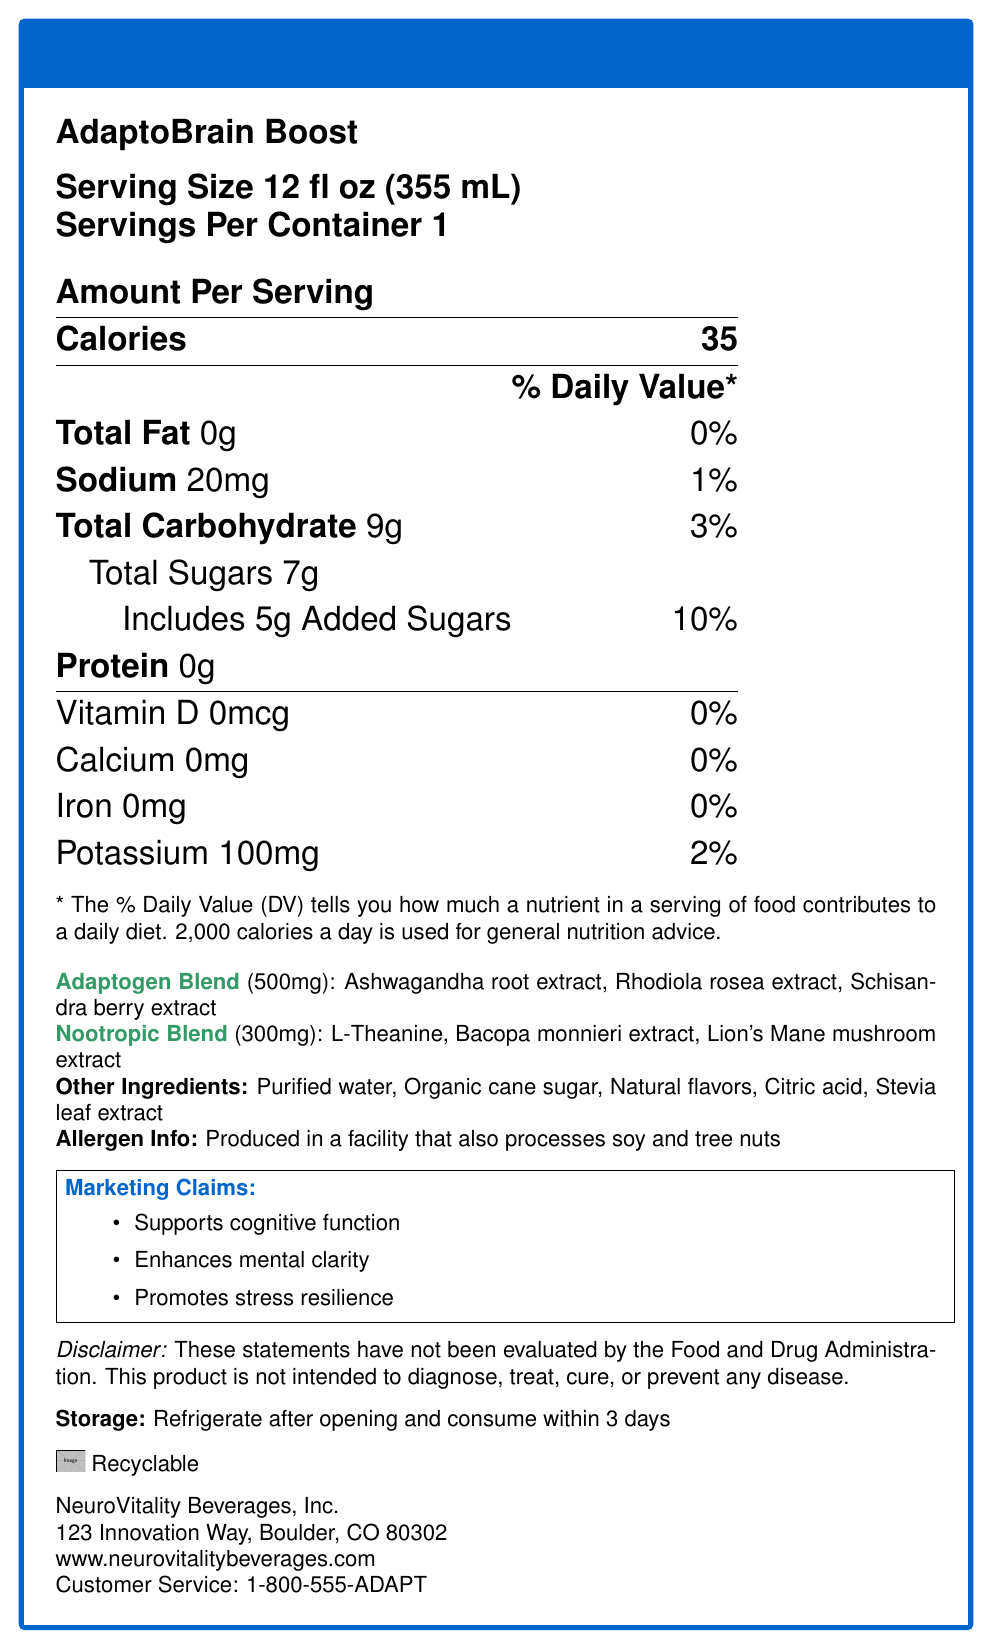what is the serving size of the AdaptoBrain Boost beverage? The serving size is clearly mentioned as "12 fl oz (355 mL)" on the document.
Answer: 12 fl oz (355 mL) how many grams of sugar are in one serving of AdaptoBrain Boost? The document lists the total sugars amount as 7g per serving.
Answer: 7g what percentage of the daily value is the sodium content in one serving? The sodium content is listed as 20mg, which is 1% of the daily value.
Answer: 1% what unique ingredients are found in the adaptogen blend? The adaptogen blend includes Ashwagandha root extract, Rhodiola rosea extract, and Schisandra berry extract.
Answer: Ashwagandha root extract, Rhodiola rosea extract, Schisandra berry extract which types of nootropics are included in the AdaptoBrain Boost beverage? The nootropic blend contains L-Theanine, Bacopa monnieri extract, and Lion's Mane mushroom extract.
Answer: L-Theanine, Bacopa monnieri extract, Lion's Mane mushroom extract what is the calorie count per serving of AdaptoBrain Boost? The document states that there are 35 calories per serving.
Answer: 35 how should this product be stored after opening? The storage instructions state to refrigerate after opening and consume within 3 days.
Answer: Refrigerate after opening and consume within 3 days which company produces AdaptoBrain Boost? The company listed is NeuroVitality Beverages, Inc.
Answer: NeuroVitality Beverages, Inc. what are the daily value percentages of vitamin D and calcium in one serving? Both vitamin D and calcium are listed as 0% of the daily value.
Answer: 0% for both is the product recyclable? The document indicates that the product is recyclable.
Answer: Yes which of the following ingredients is not in AdaptoBrain Boost? A. Organic cane sugar B. Natural flavors C. Artificial sweeteners The document lists organic cane sugar and natural flavors but does not mention artificial sweeteners.
Answer: C. Artificial sweeteners how many servings are in one container of AdaptoBrain Boost? A. 1 B. 2 C. 3 D. 4 The document clearly states that there is 1 serving per container.
Answer: A. 1 does AdaptoBrain Boost contain any protein? The document lists protein content as 0g.
Answer: No is the following statement true or false: "AdaptoBrain Boost supports cognitive function and mental clarity." The marketing claims mention that the beverage supports cognitive function and enhances mental clarity.
Answer: True can I determine the price of AdaptoBrain Boost from the document? The document does not provide any information about the price.
Answer: Cannot be determined summarize the key points provided in the Nutrition Facts Label for AdaptoBrain Boost. The summary describes the nutritional content, special blends, additional ingredients, allergen information, marketing claims, and storage instructions of AdaptoBrain Boost, along with the company's information and product's recyclability.
Answer: AdaptoBrain Boost is a functional beverage with 35 calories per 12 fl oz serving. It includes 0g of fat, 20mg of sodium (1% DV), 9g of total carbohydrates (3% DV), 7g of sugars including 5g of added sugars (10% DV), and 100mg of potassium (2% DV). It contains no protein, vitamin D, calcium, or iron. The beverage features a 500mg adaptogen blend consisting of Ashwagandha root extract, Rhodiola rosea extract, and Schisandra berry extract, as well as a 300mg nootropic blend of L-Theanine, Bacopa monnieri extract, and Lion's Mane mushroom extract. Additional ingredients include purified water, organic cane sugar, natural flavors, citric acid, and stevia leaf extract. It is produced in a facility that processes soy and tree nuts, supports cognitive function, enhances mental clarity, and promotes stress resilience. The product should be refrigerated after opening and consumed within 3 days and is recyclable. It is produced by NeuroVitality Beverages, Inc. 